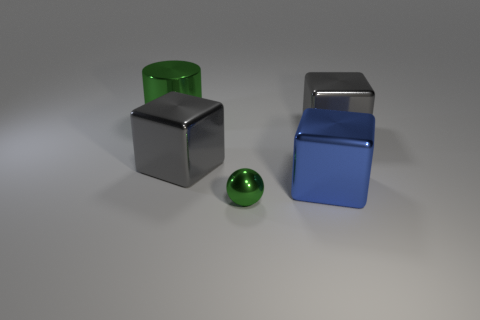The green thing that is made of the same material as the cylinder is what size?
Ensure brevity in your answer.  Small. How many shiny objects are small balls or brown spheres?
Give a very brief answer. 1. What is the size of the blue shiny thing?
Offer a terse response. Large. Does the blue cube have the same size as the metallic sphere?
Your answer should be very brief. No. There is a small green ball to the left of the blue metal block; what is its material?
Your answer should be very brief. Metal. There is a gray thing left of the tiny object; is there a large gray block that is on the left side of it?
Your answer should be very brief. No. Do the small green thing and the blue object have the same shape?
Provide a succinct answer. No. What is the shape of the small green thing that is the same material as the big green cylinder?
Keep it short and to the point. Sphere. Do the green metal object in front of the big green metal cylinder and the gray cube that is to the left of the tiny green metallic thing have the same size?
Your answer should be very brief. No. Are there more large blue blocks that are to the left of the large blue metallic object than big green shiny objects that are left of the big green cylinder?
Provide a short and direct response. No. 